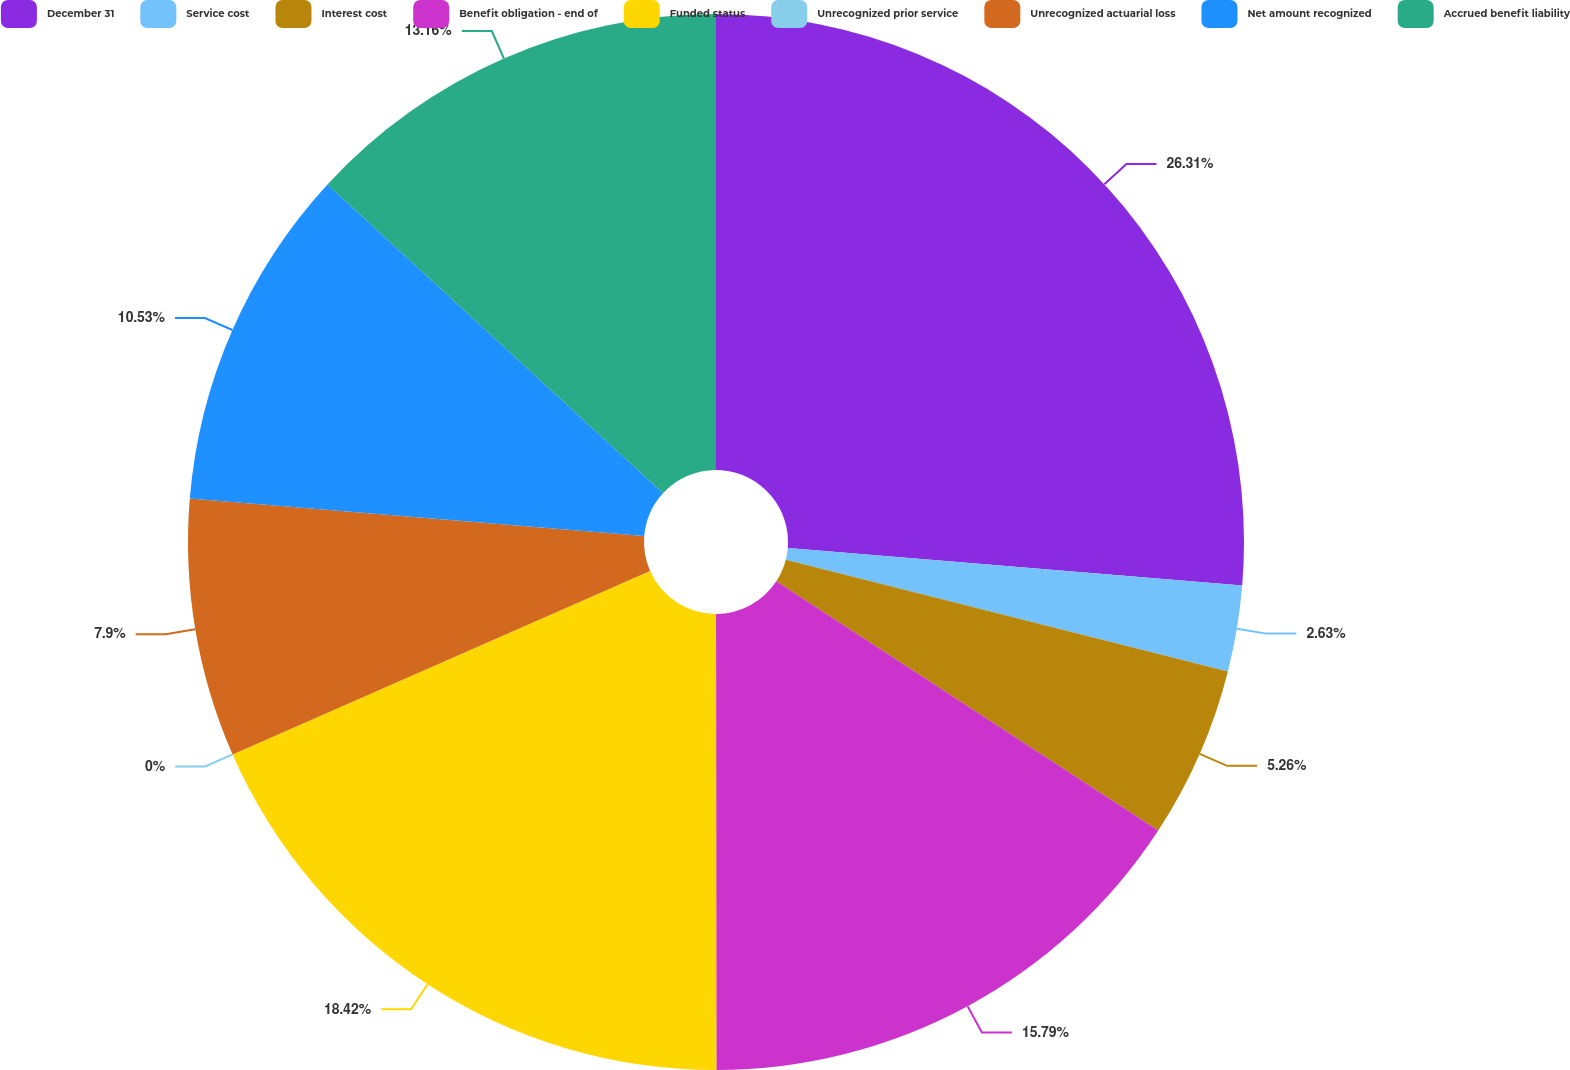Convert chart. <chart><loc_0><loc_0><loc_500><loc_500><pie_chart><fcel>December 31<fcel>Service cost<fcel>Interest cost<fcel>Benefit obligation - end of<fcel>Funded status<fcel>Unrecognized prior service<fcel>Unrecognized actuarial loss<fcel>Net amount recognized<fcel>Accrued benefit liability<nl><fcel>26.31%<fcel>2.63%<fcel>5.26%<fcel>15.79%<fcel>18.42%<fcel>0.0%<fcel>7.9%<fcel>10.53%<fcel>13.16%<nl></chart> 